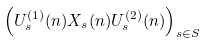<formula> <loc_0><loc_0><loc_500><loc_500>\left ( U _ { s } ^ { ( 1 ) } ( n ) X _ { s } ( n ) U _ { s } ^ { ( 2 ) } ( n ) \right ) _ { s \in S }</formula> 